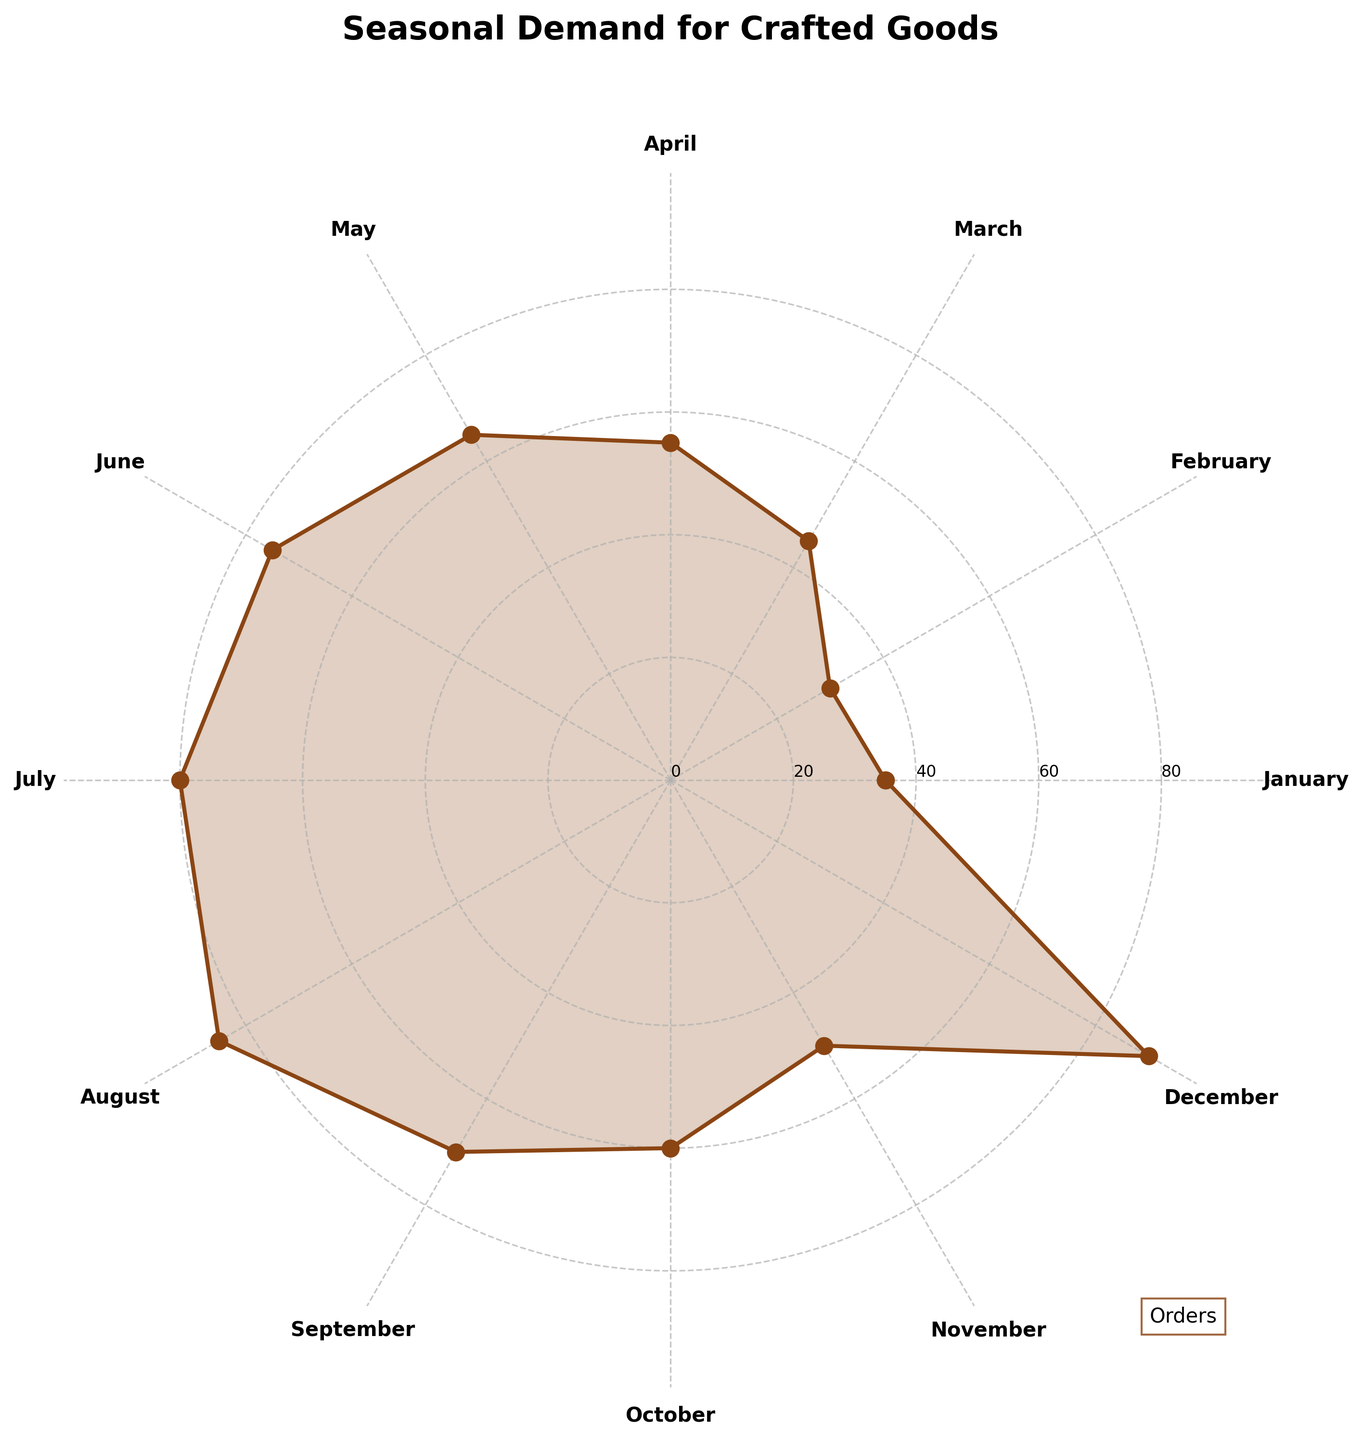What is the title of the chart? The title is usually found at the top of the chart. In this chart, it is clearly marked as "Seasonal Demand for Crafted Goods."
Answer: Seasonal Demand for Crafted Goods Which month has the highest number of orders? To find the month with the highest number of orders, look for the segment that extends the furthest from the center of the chart. In this case, it's December.
Answer: December What color is used to fill the area beneath the plotted line? The color used is a shade of brown often associated with wooden objects, typically resembling #8B4513.
Answer: Brown How many months showed an order quantity of 60 or more? To determine this, locate the data points or sections that extend beyond the 60-mark on the chart. The months that meet this criterion are April, May, June, July, August, September, October, and December.
Answer: 8 In which month do orders start to consistently stay above 60? Identify the point where the orders first reach 60 and maintain that level or higher in the succeeding months. From the chart, June is the first month where this level is consistently met.
Answer: June Which month has the lowest number of orders? To find the month with the lowest number of orders, look for the segment that is closest to the center of the chart. In this chart, that month is February.
Answer: February What is the difference in the number of orders between August and September? To solve this, subtract the number of orders in September from those in August. August has 85 orders and September has 70, so 85 - 70 yields 15.
Answer: 15 What is the total number of orders from May to August inclusive? Sum the orders from May to August: May (65) + June (75) + July (80) + August (85) = 305.
Answer: 305 Which month had more orders: April or October? By comparing the segments for April and October, April has 55 orders and October has 60. Therefore, October had more orders.
Answer: October Are there any months with exactly 50 orders? By examining the chart, the segment for November reaches the 50-mark, indicating exactly 50 orders.
Answer: November 